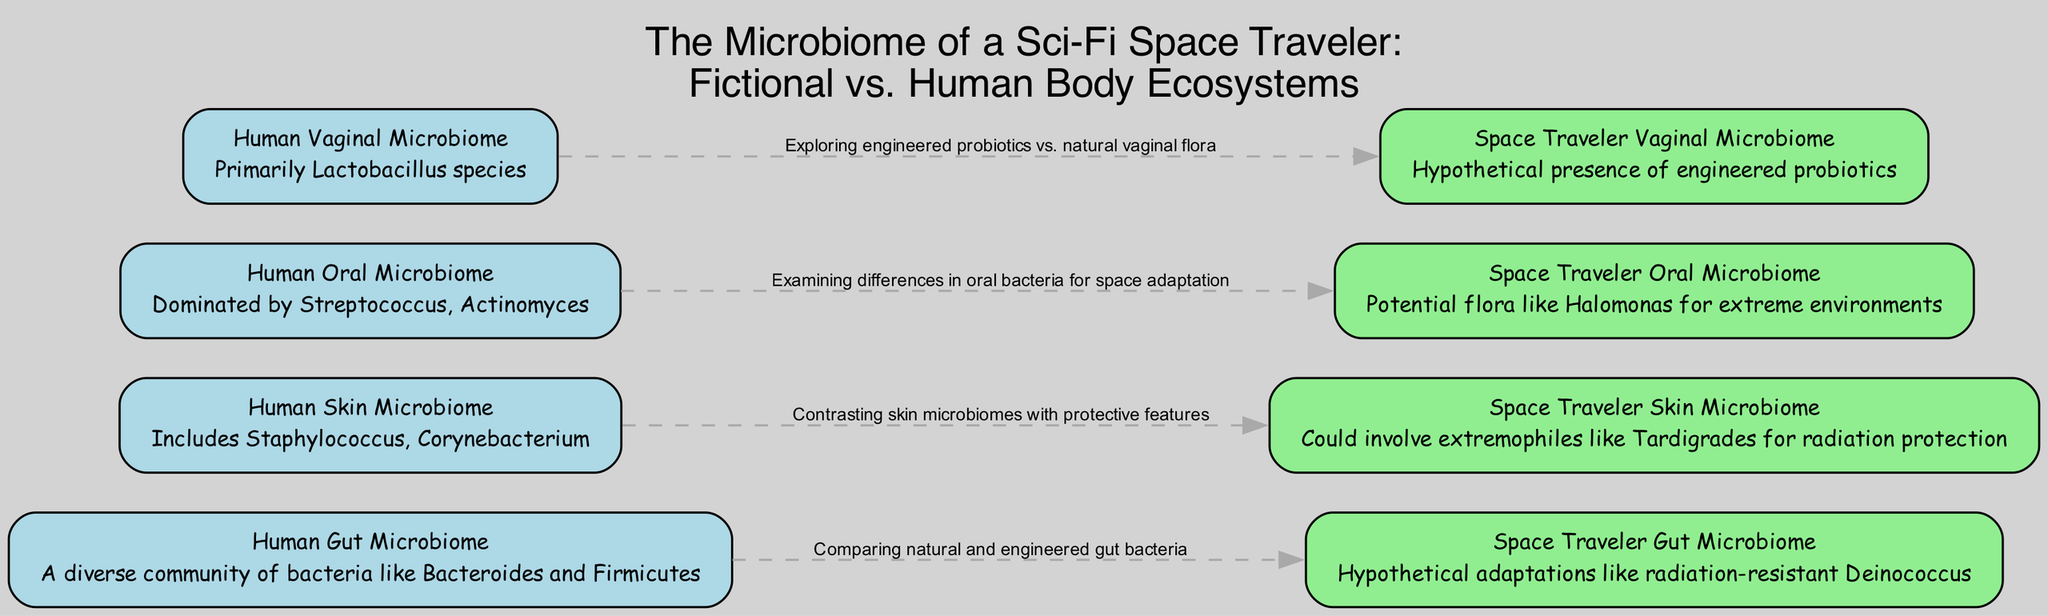What is the label of the node representing the human gut microbiome? The node labeled "Human Gut Microbiome" is defined in the data with the relevant description. This can be identified by examining the list of nodes for the specific ID "human_gut".
Answer: Human Gut Microbiome How many nodes are present in the diagram? The diagram features a total of 8 nodes, as indicated by the data provided. This number is counted from the nodes section, which lists each unique microbiome representation.
Answer: 8 What type of bacteria is mentioned for the space traveler gut microbiome? The description for the "Space Traveler Gut Microbiome" node specifies "radiation-resistant Deinococcus" as a potential bacteria, thus answering the query about the specific type mentioned.
Answer: Deinococcus What is a protective feature of the space traveler skin microbiome? The "Space Traveler Skin Microbiome" description points out that it could involve extremophiles like Tardigrades for radiation protection, providing an answer directly referenced in the diagram's content.
Answer: Tardigrades Which microbiome involves engineered probiotics in the space traveler context? Looking at the "Space Traveler Vaginal Microbiome", the description explicitly states the hypothetical presence of engineered probiotics, thereby indicating which microbiome entails this feature.
Answer: Vaginal Microbiome What is the primary bacterial genus found in the human vaginal microbiome? The "Human Vaginal Microbiome" description states "Primarily Lactobacillus species". This information is straightforwardly stated in the node's description, leading directly to the answer.
Answer: Lactobacillus Which microbiome pair compares natural and engineered bacteria? The edge between the "Human Gut Microbiome" and "Space Traveler Gut Microbiome" nodes explicitly states the comparison, linking the two concepts directly within the diagram.
Answer: Gut Microbiome What kind of extremophile might be found in the space traveler's oral microbiome? The "Space Traveler Oral Microbiome" node mentions "Halomonas" as the potential flora adapted for extreme environments, thus answering the question based on the node's information.
Answer: Halomonas 